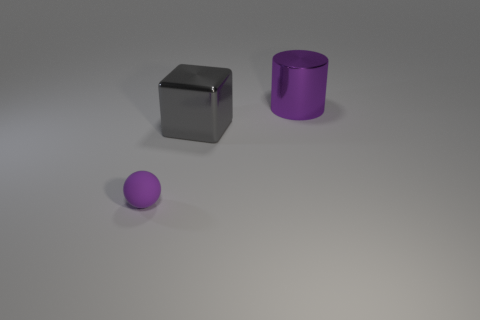How many purple shiny things are the same shape as the gray metal object?
Ensure brevity in your answer.  0. Is the shape of the large gray object the same as the purple object that is behind the rubber ball?
Your answer should be compact. No. There is a thing that is the same color as the big shiny cylinder; what is its shape?
Offer a very short reply. Sphere. Is there a gray thing made of the same material as the purple cylinder?
Give a very brief answer. Yes. Is there any other thing that is the same material as the small purple ball?
Ensure brevity in your answer.  No. The big object that is to the left of the purple thing right of the purple ball is made of what material?
Provide a succinct answer. Metal. There is a purple thing that is behind the purple thing that is to the left of the large object to the right of the big block; what size is it?
Your answer should be very brief. Large. How many other objects are the same shape as the gray shiny thing?
Provide a succinct answer. 0. There is a metal object right of the gray cube; is its color the same as the object that is in front of the large gray cube?
Your answer should be compact. Yes. There is a shiny cube that is the same size as the purple cylinder; what color is it?
Your answer should be very brief. Gray. 